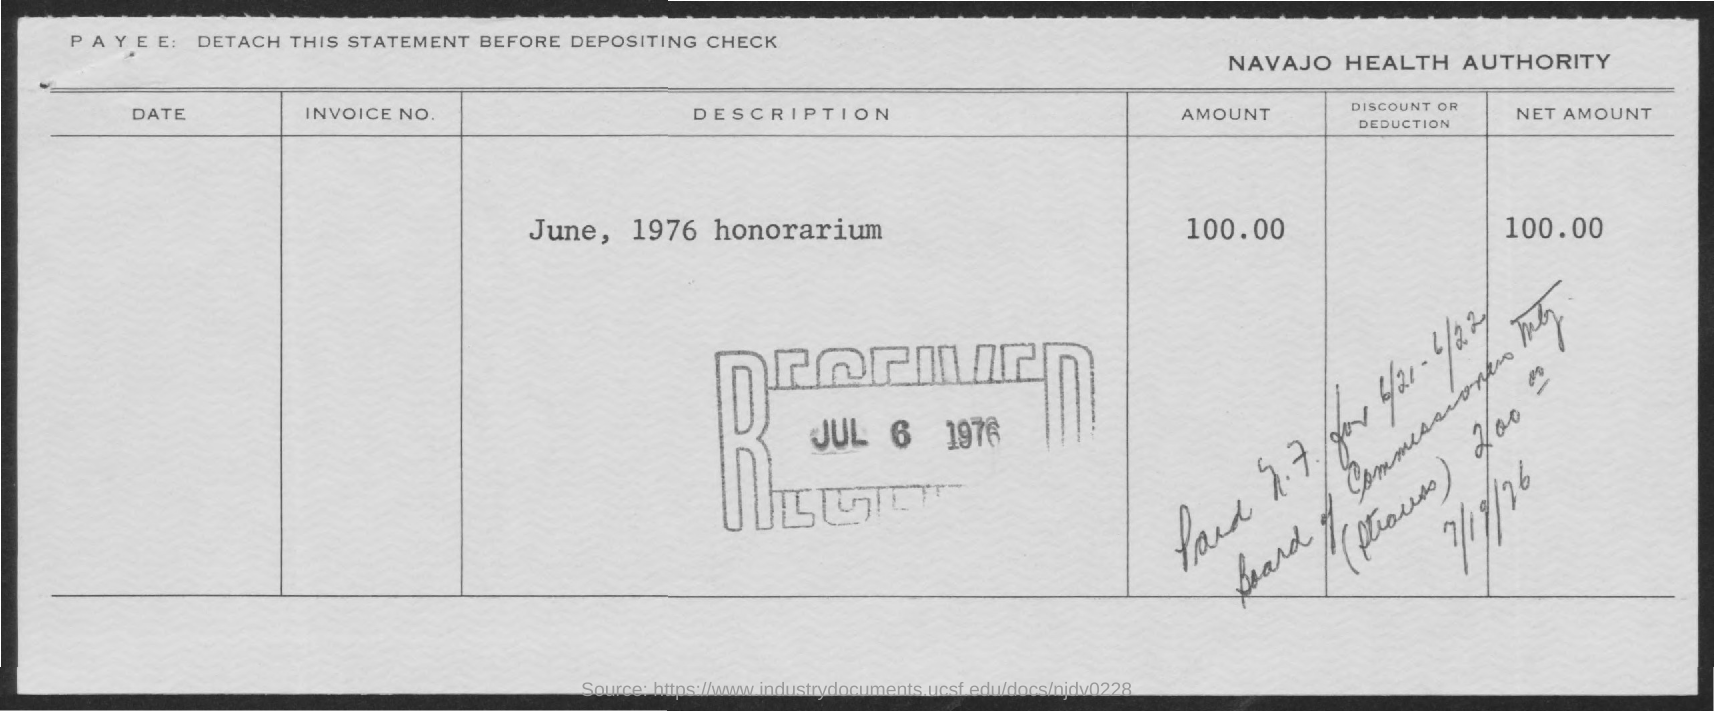Mention a couple of crucial points in this snapshot. On July 6th, 1976, the honorarium was received. The honorarium was dated on June 1976. The net amount of Honorarium is 100.00. The Navajo Health Authority is the name of a healthcare organization. The Honorarium is $100.00. 